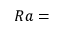<formula> <loc_0><loc_0><loc_500><loc_500>R a =</formula> 